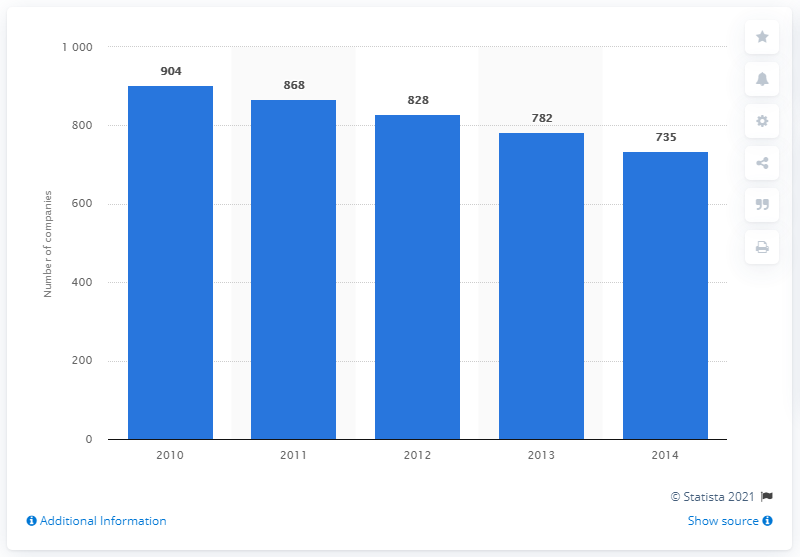Draw attention to some important aspects in this diagram. In 2010, there were 904 companies in the medical device industry in the United States. The number of companies in the U.S. medical device industry from 2010 to 2012 was approximately 2,600. In 2010, there were 904 companies in the U.S. medical device industry. 